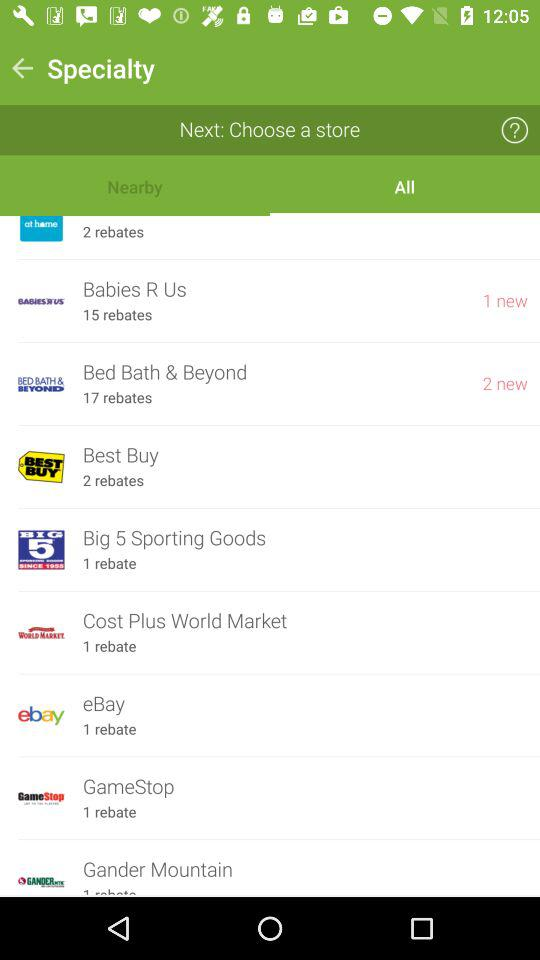How many rebates does eBay have? eBay have 1 rebate. 